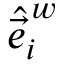Convert formula to latex. <formula><loc_0><loc_0><loc_500><loc_500>\hat { \vec { e } } _ { i } ^ { \, w }</formula> 